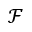<formula> <loc_0><loc_0><loc_500><loc_500>\mathcal { F }</formula> 